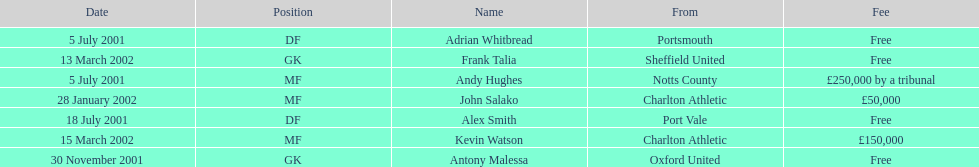Who transferred after 30 november 2001? John Salako, Frank Talia, Kevin Watson. 